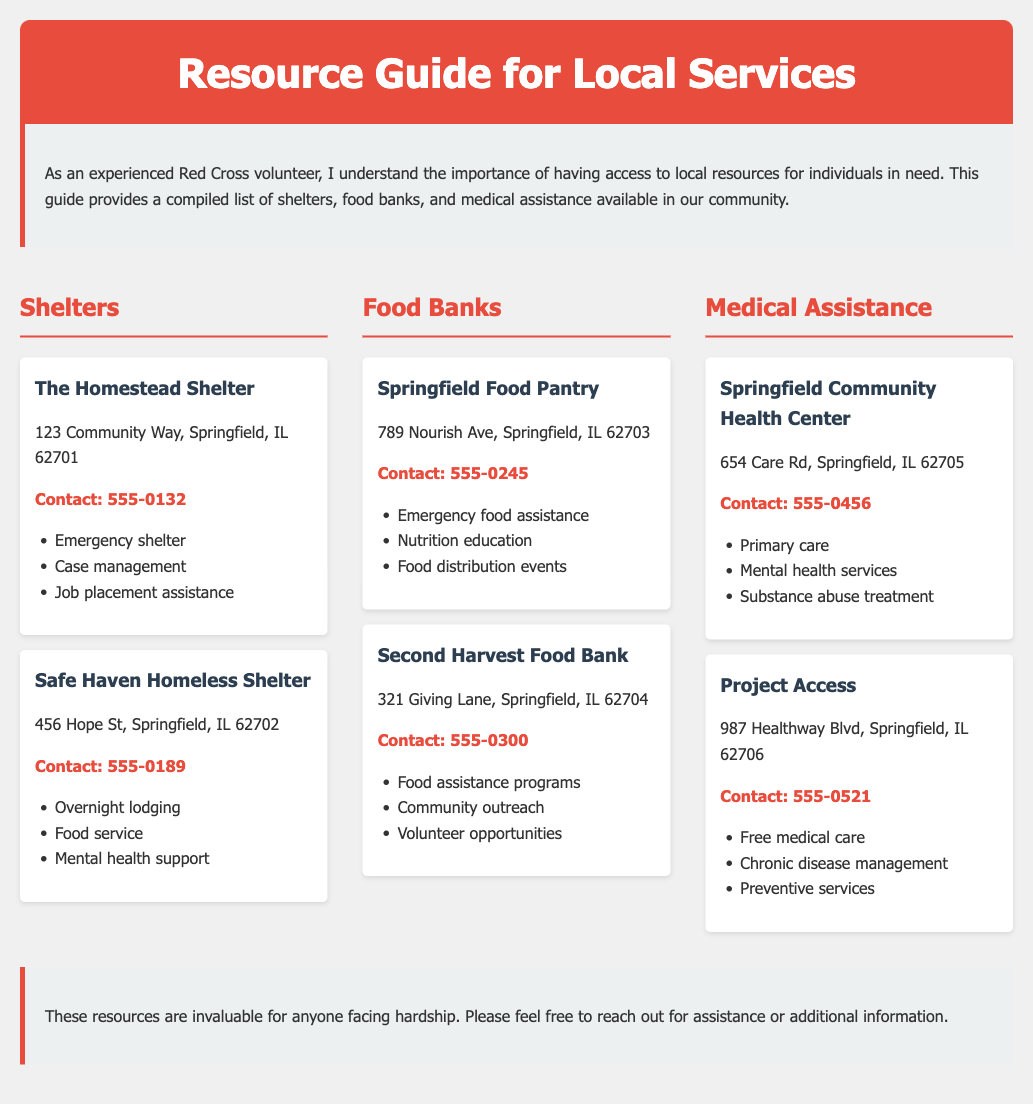What is the contact number for The Homestead Shelter? The contact number is listed under The Homestead Shelter section in the document.
Answer: 555-0132 Where is the Springfield Food Pantry located? The location is provided in the Springfield Food Pantry resource item in the document.
Answer: 789 Nourish Ave, Springfield, IL 62703 What type of assistance does Project Access offer? The document lists the services provided by Project Access under the Medical Assistance section.
Answer: Free medical care How many shelters are listed in the document? The total number of shelters can be counted from the resources section of the document.
Answer: 2 What is the primary service provided by the Springfield Community Health Center? The primary service is mentioned in the description of the clinic in the Medical Assistance section.
Answer: Primary care Which food bank provides nutrition education? The service can be found in the description of Springfield Food Pantry.
Answer: Springfield Food Pantry What is the address of Safe Haven Homeless Shelter? The address is provided in the resource item for Safe Haven Homeless Shelter.
Answer: 456 Hope St, Springfield, IL 62702 What support does Safe Haven offer? The document contains a list of services offered by Safe Haven under its description.
Answer: Mental health support How are resources categorized in the document? The document has sections that explicitly categorize resources in distinct groupings for easy navigation.
Answer: Shelters, Food Banks, Medical Assistance 